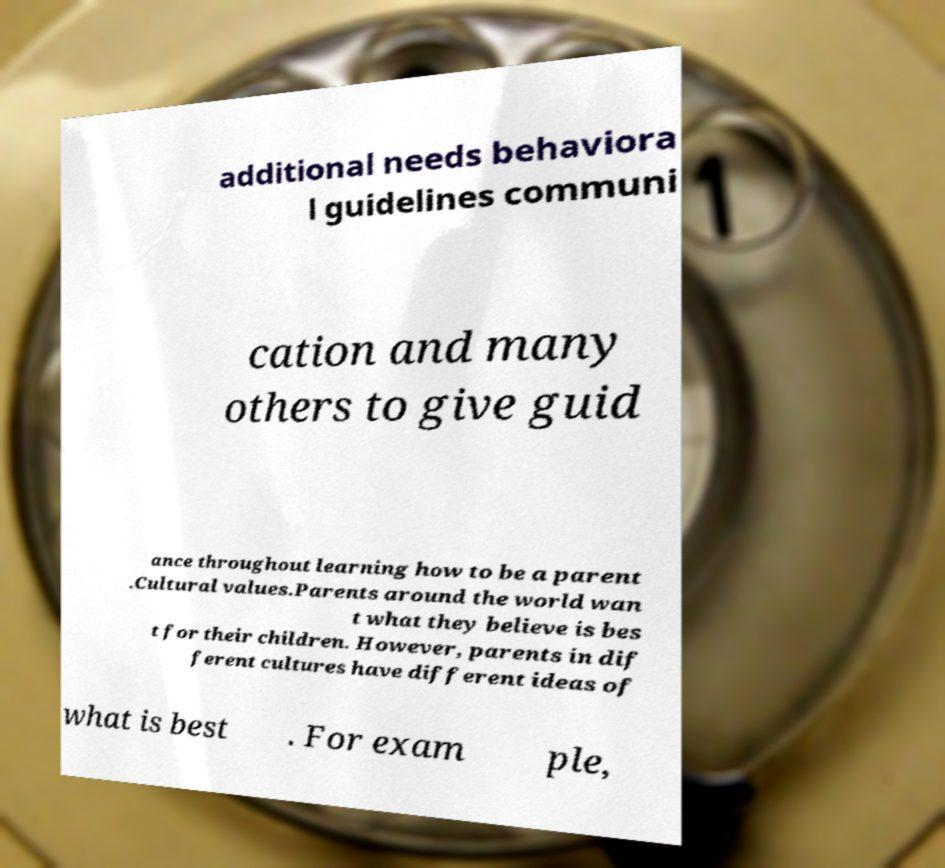There's text embedded in this image that I need extracted. Can you transcribe it verbatim? additional needs behaviora l guidelines communi cation and many others to give guid ance throughout learning how to be a parent .Cultural values.Parents around the world wan t what they believe is bes t for their children. However, parents in dif ferent cultures have different ideas of what is best . For exam ple, 